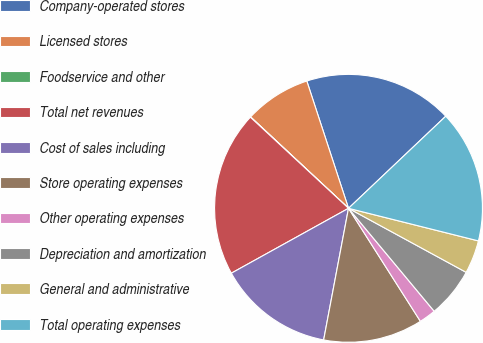<chart> <loc_0><loc_0><loc_500><loc_500><pie_chart><fcel>Company-operated stores<fcel>Licensed stores<fcel>Foodservice and other<fcel>Total net revenues<fcel>Cost of sales including<fcel>Store operating expenses<fcel>Other operating expenses<fcel>Depreciation and amortization<fcel>General and administrative<fcel>Total operating expenses<nl><fcel>17.97%<fcel>8.01%<fcel>0.04%<fcel>19.96%<fcel>13.98%<fcel>11.99%<fcel>2.03%<fcel>6.02%<fcel>4.02%<fcel>15.98%<nl></chart> 